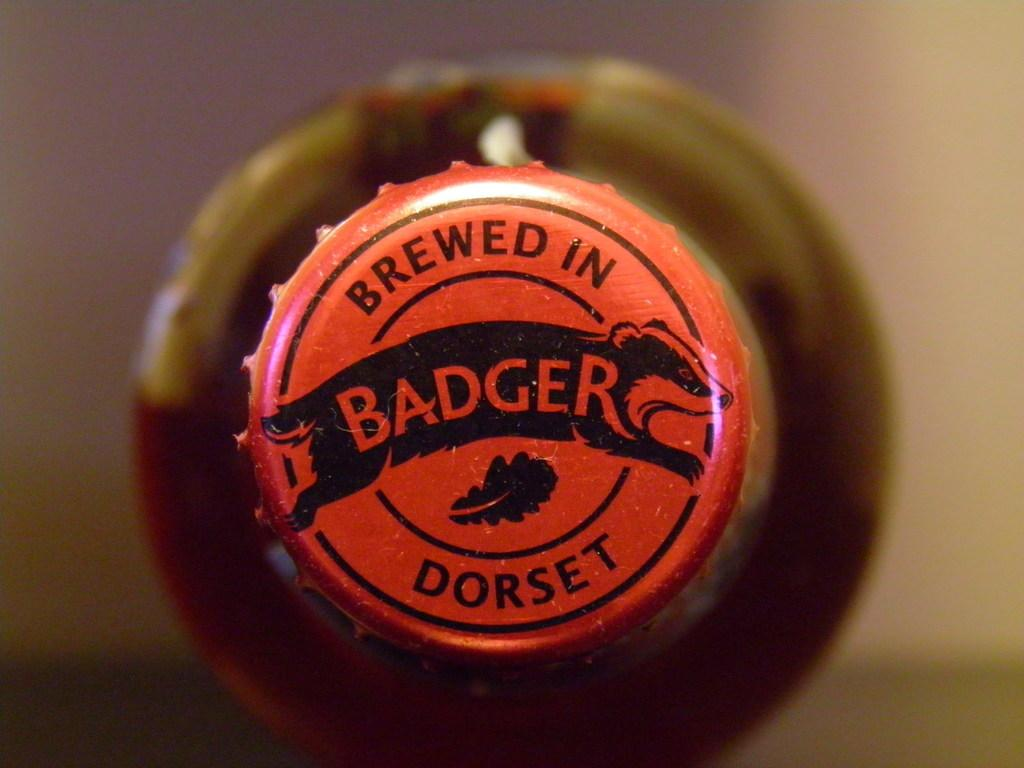What object is present in the image? There is a bottle in the image. What feature does the bottle have? The bottle has a cap. Is there any text on the bottle? Yes, there is text written on the bottle. How would you describe the background of the image? The background of the image is blurred. Can you see any pigs or flowers in the image? No, there are no pigs or flowers present in the image. What type of surprise is hidden in the bottle? There is no indication of a surprise hidden in the bottle, as the image only shows the bottle with a cap and text. 